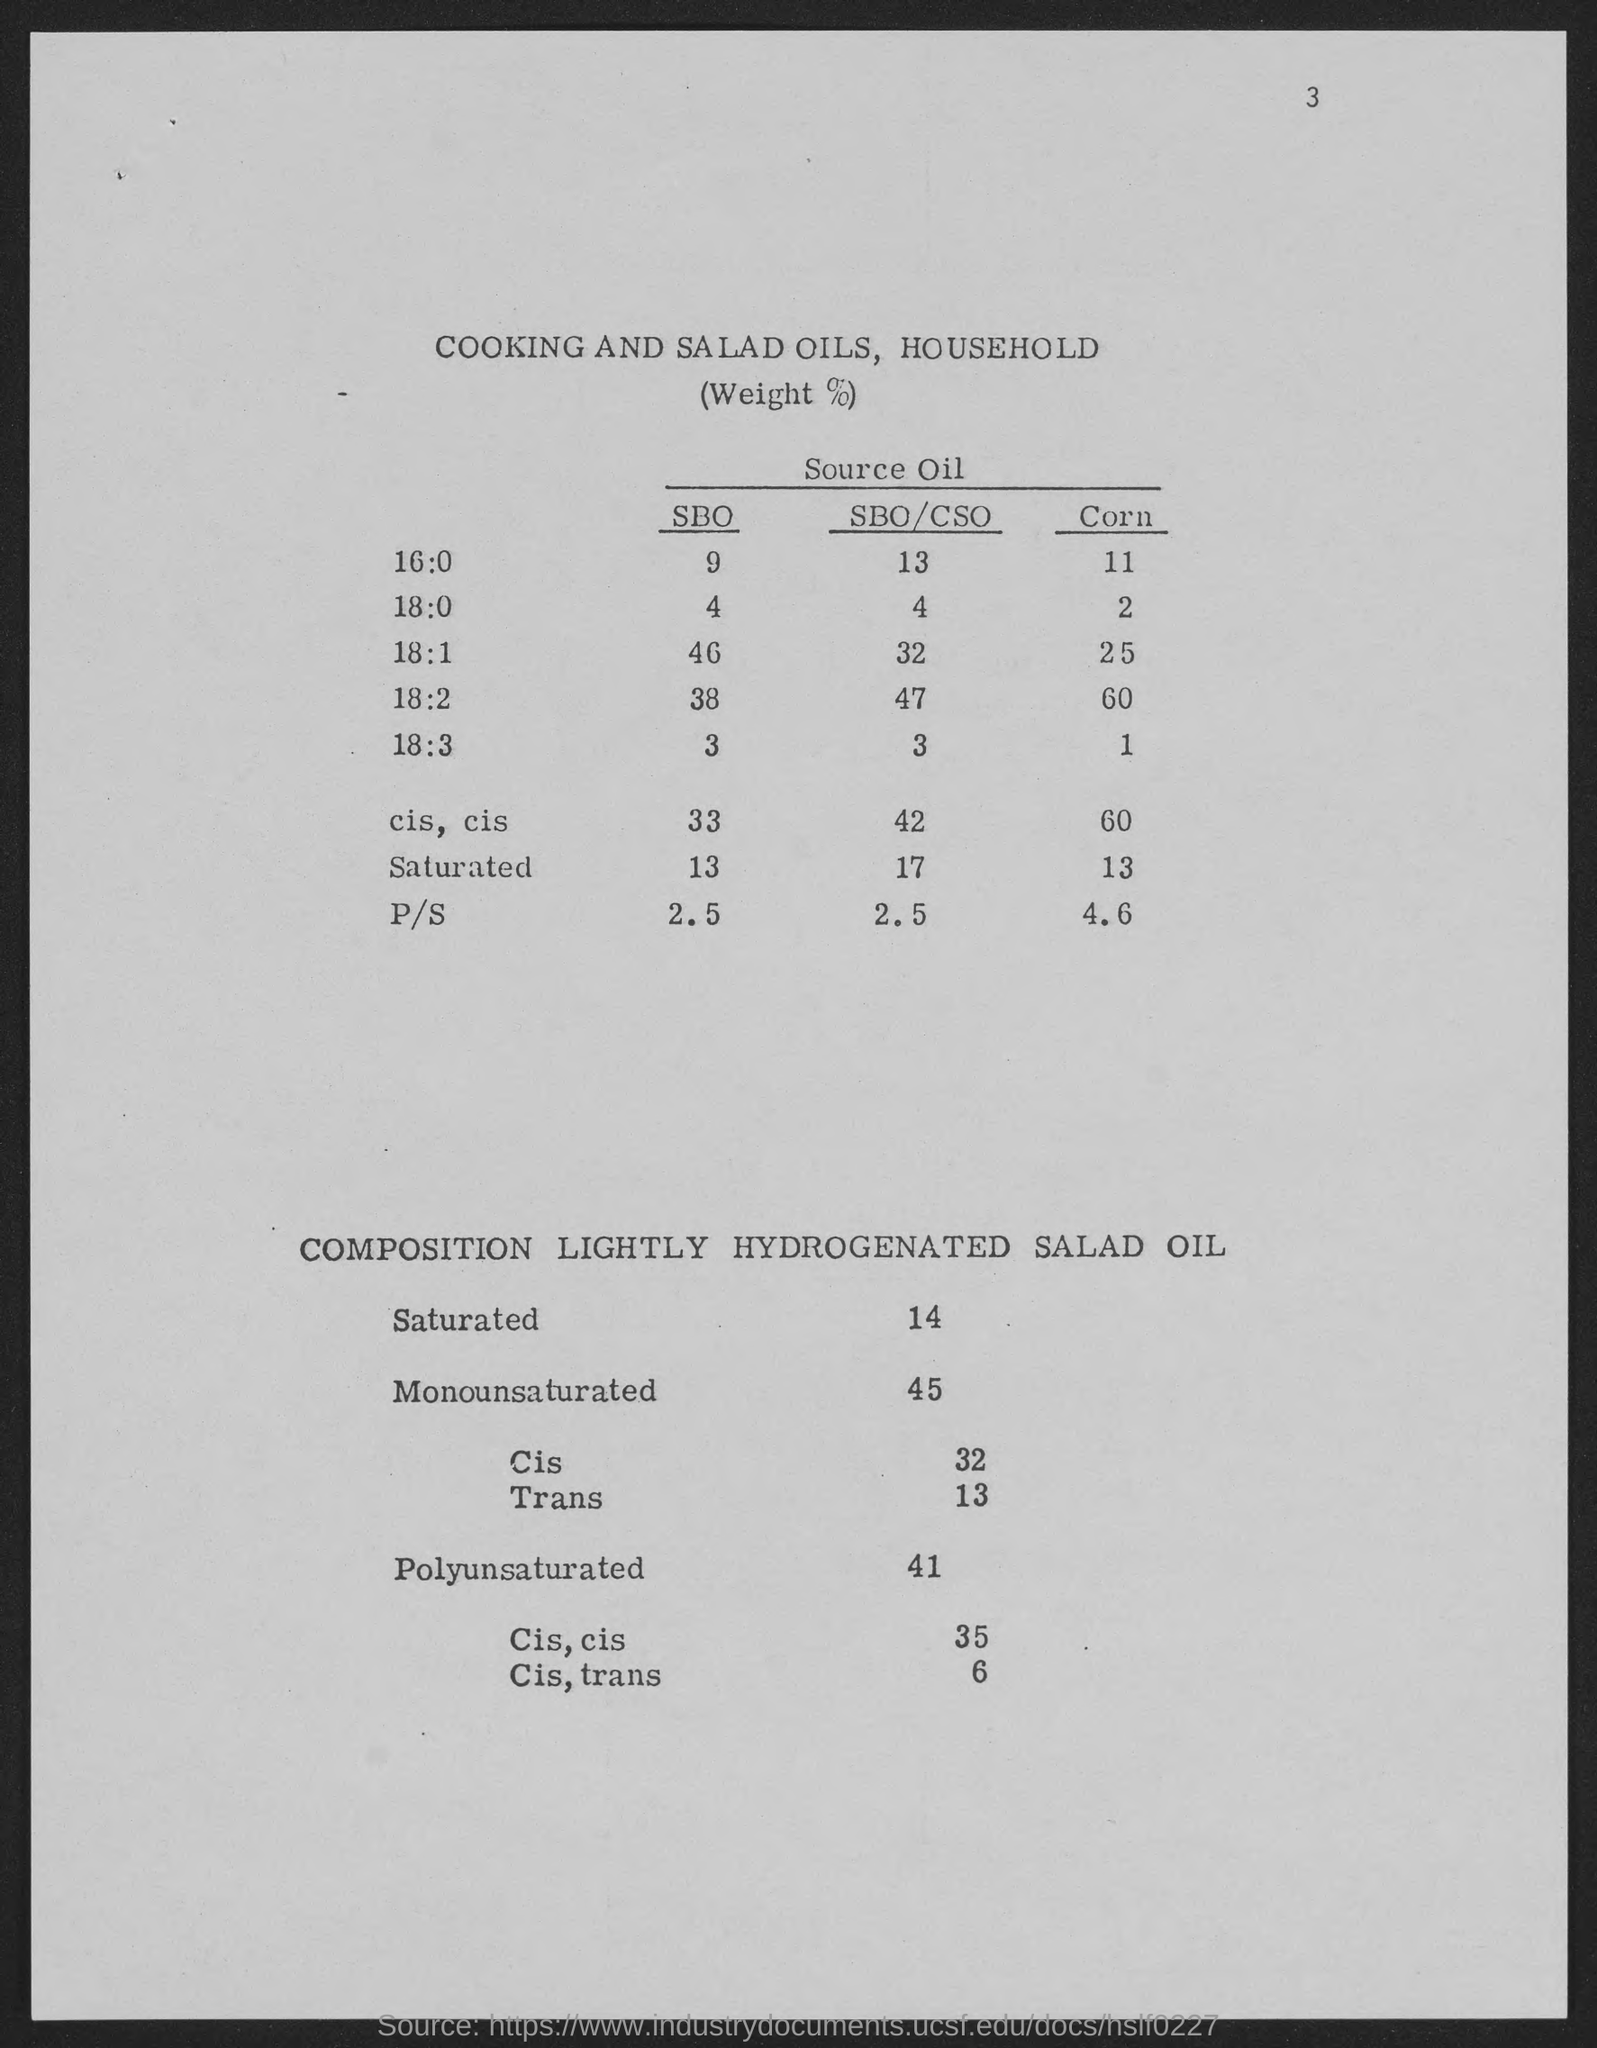List a handful of essential elements in this visual. The number at the top-right corner of the page is 3. 